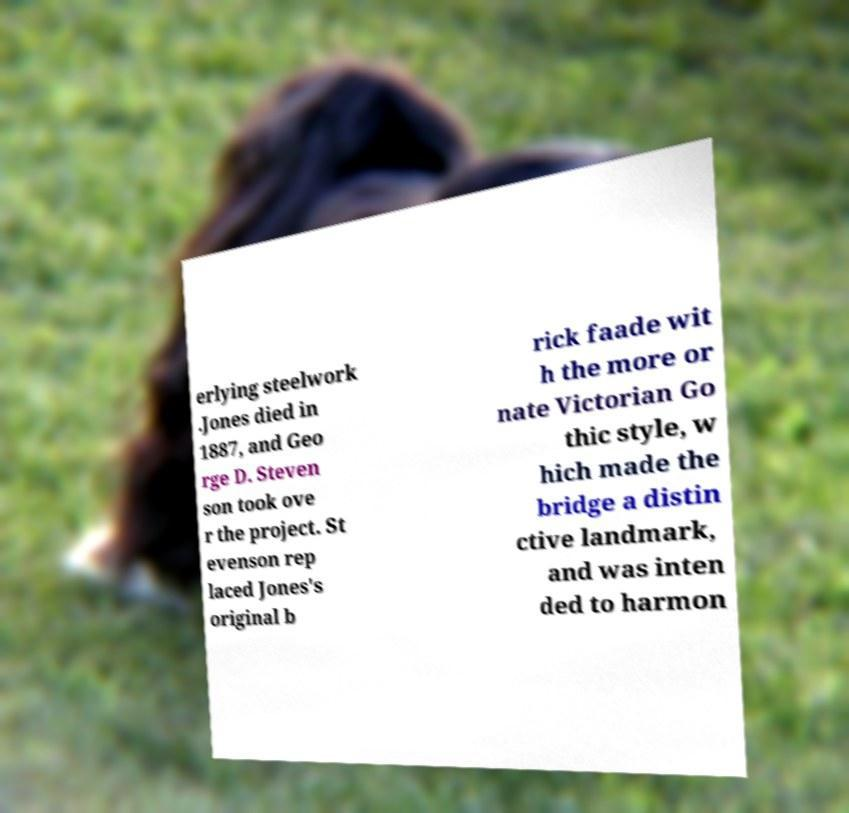Please read and relay the text visible in this image. What does it say? erlying steelwork .Jones died in 1887, and Geo rge D. Steven son took ove r the project. St evenson rep laced Jones's original b rick faade wit h the more or nate Victorian Go thic style, w hich made the bridge a distin ctive landmark, and was inten ded to harmon 